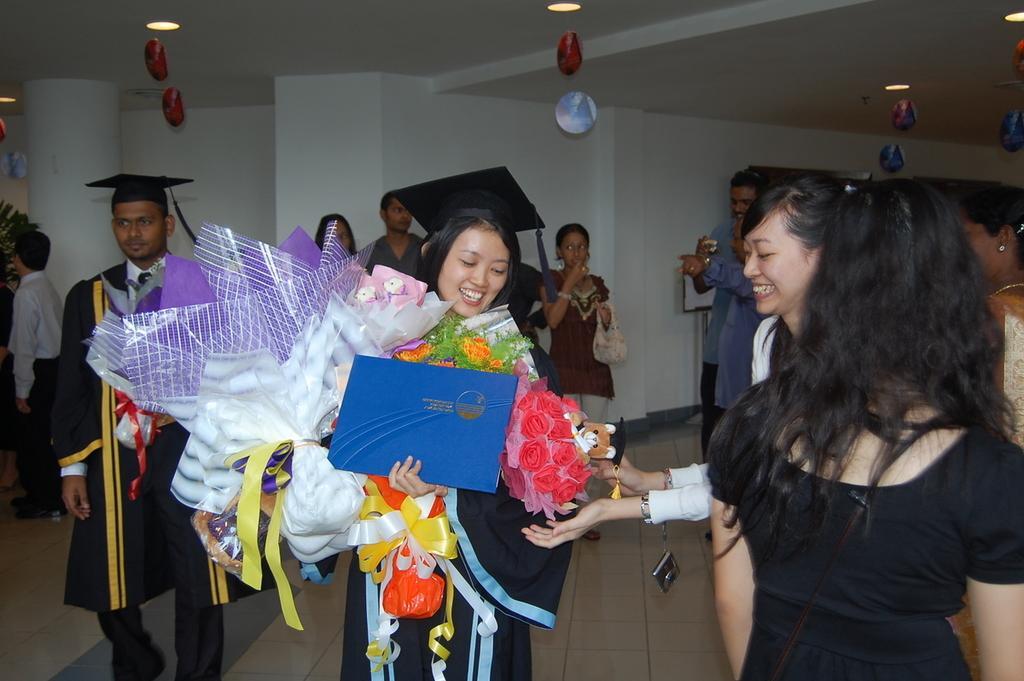Can you describe this image briefly? This image is clicked from inside the room. In this image we can see there are a few people standing on the floor. At the center of the image we can see there is a girl holding so many gifts in her hands. At the top of the image there is a ceiling. 